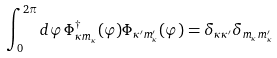<formula> <loc_0><loc_0><loc_500><loc_500>\int _ { 0 } ^ { 2 \pi } d \varphi \, \Phi _ { \kappa m _ { \kappa } } ^ { \dag } ( \varphi ) \Phi _ { \kappa ^ { \prime } m _ { \kappa } ^ { \prime } } ( \varphi ) = \delta _ { \kappa \kappa ^ { \prime } } \delta _ { m _ { \kappa } m _ { \kappa } ^ { \prime } }</formula> 